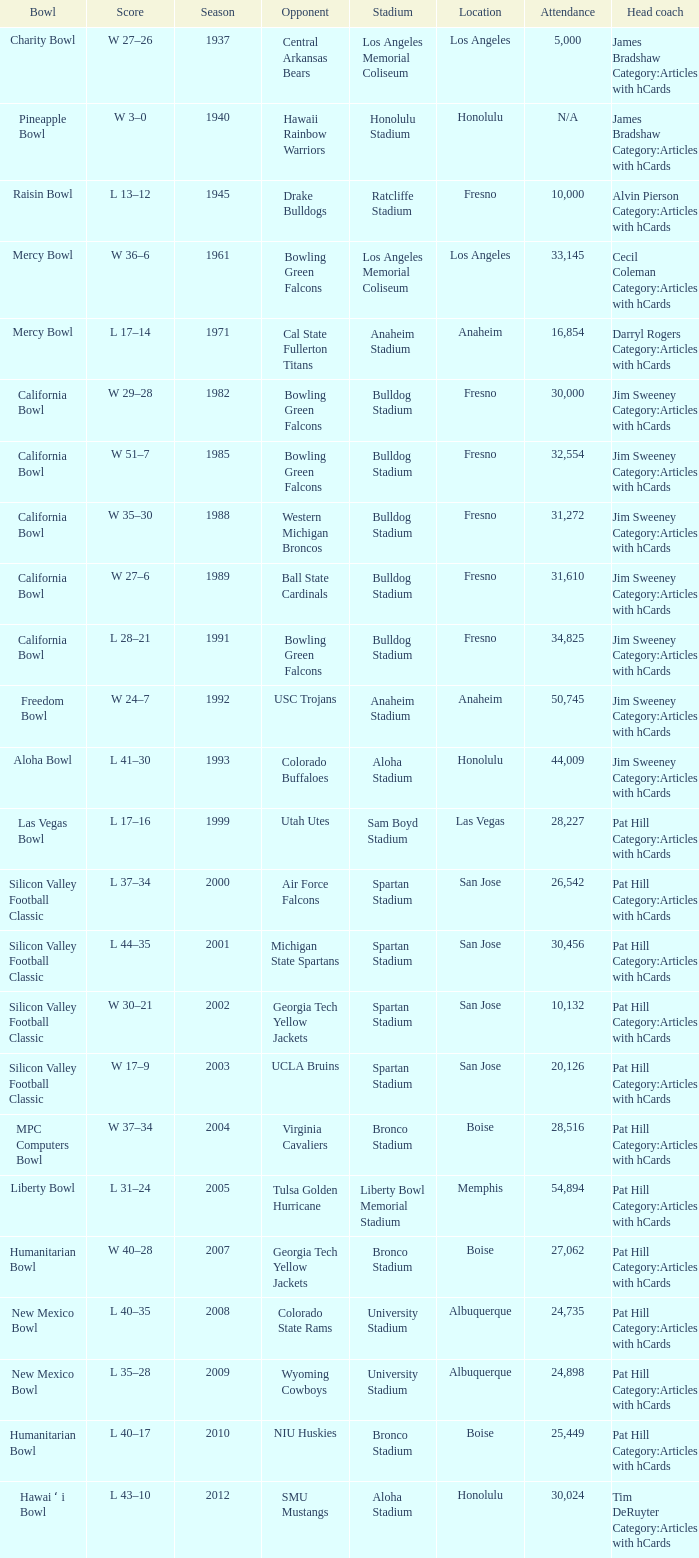What stadium had an opponent of Cal State Fullerton Titans? Anaheim Stadium. 